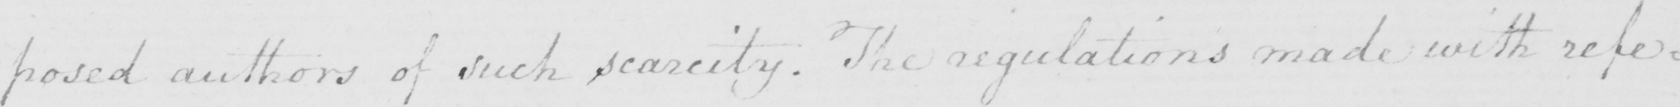Can you tell me what this handwritten text says? : posed authors of such scarcity . The regulations made with refer= 